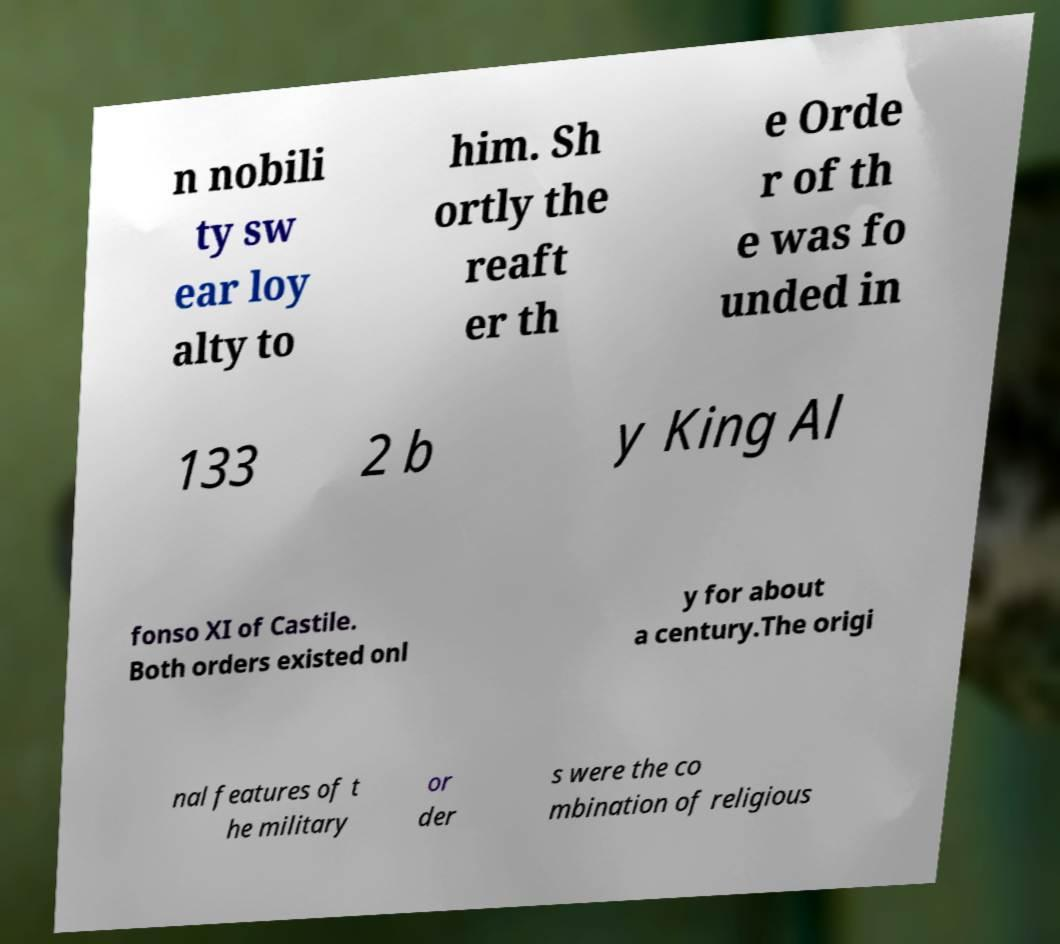Please identify and transcribe the text found in this image. n nobili ty sw ear loy alty to him. Sh ortly the reaft er th e Orde r of th e was fo unded in 133 2 b y King Al fonso XI of Castile. Both orders existed onl y for about a century.The origi nal features of t he military or der s were the co mbination of religious 